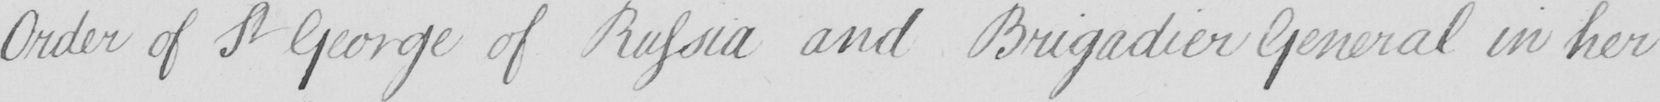What text is written in this handwritten line? Order of St George of Russia and Brigadier General in her 